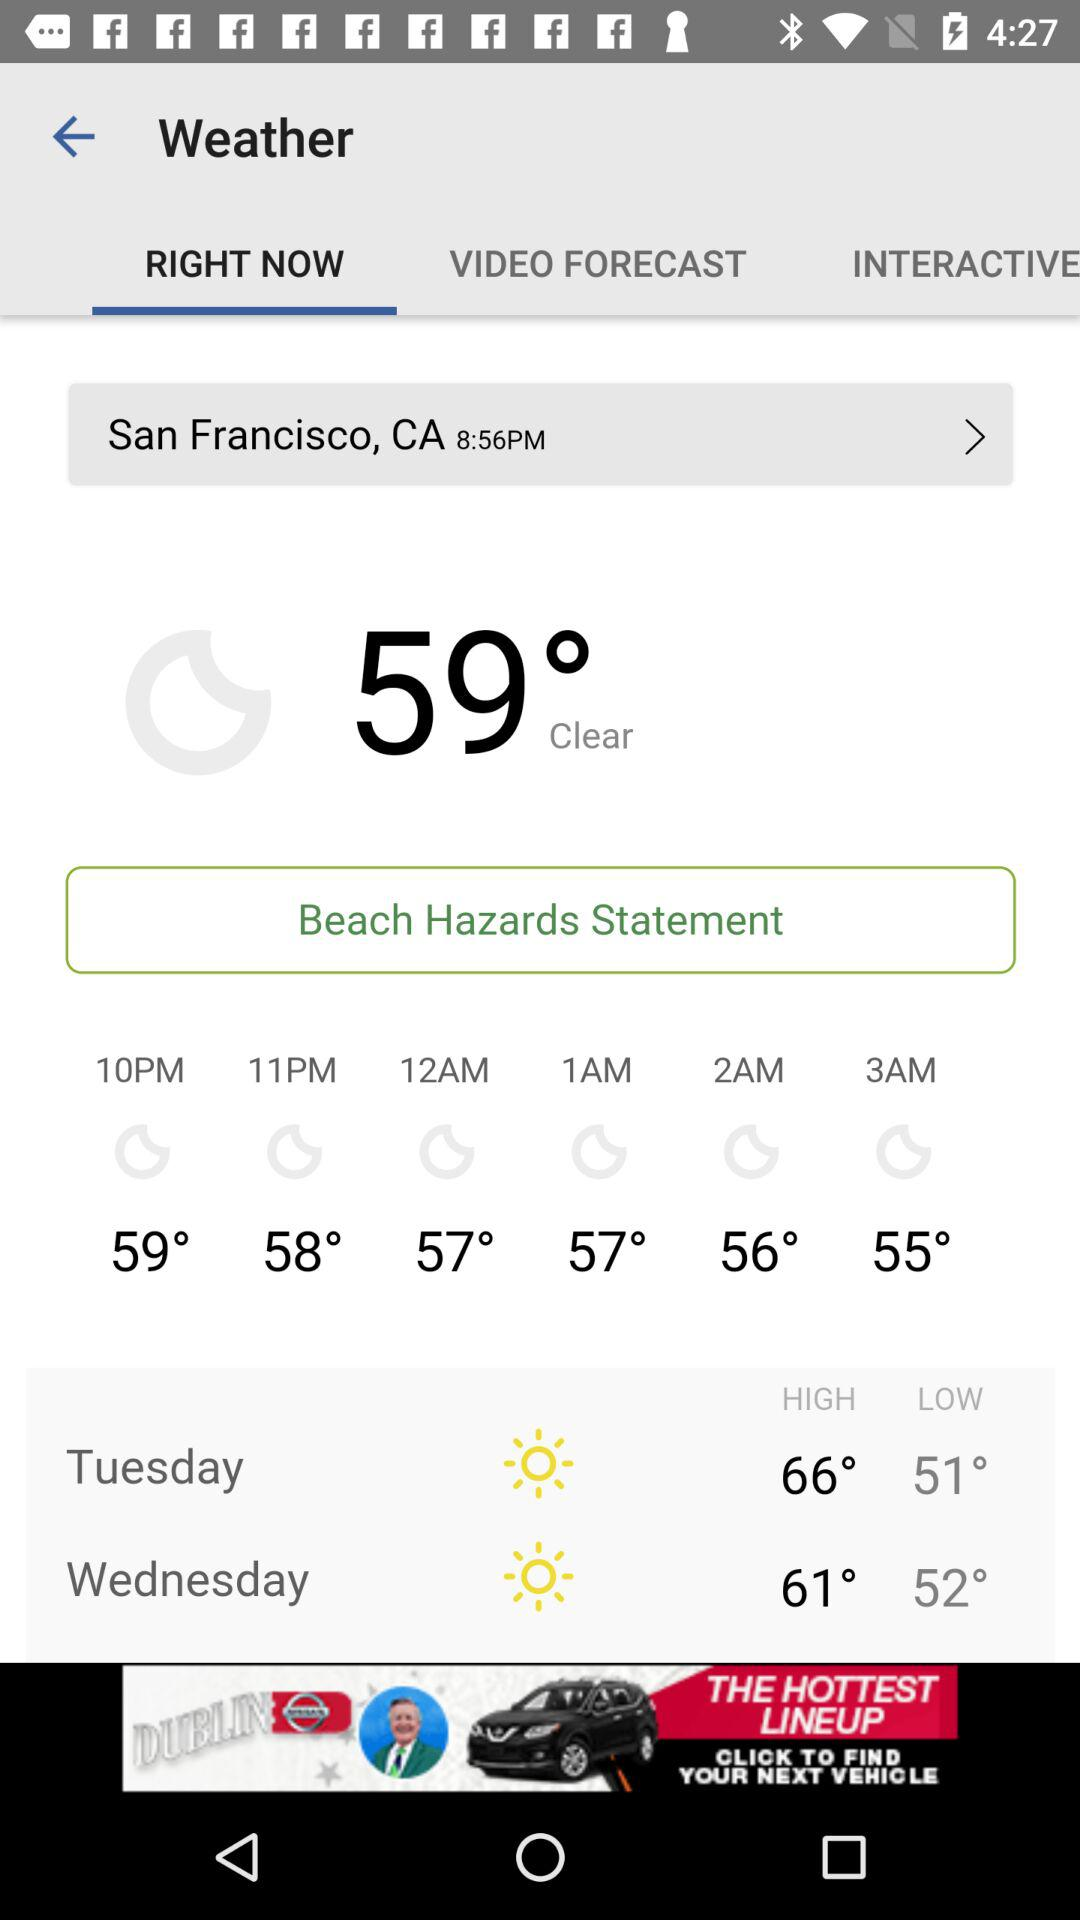What will be the low temperature on Tuesday? The low temperature is 51°. 